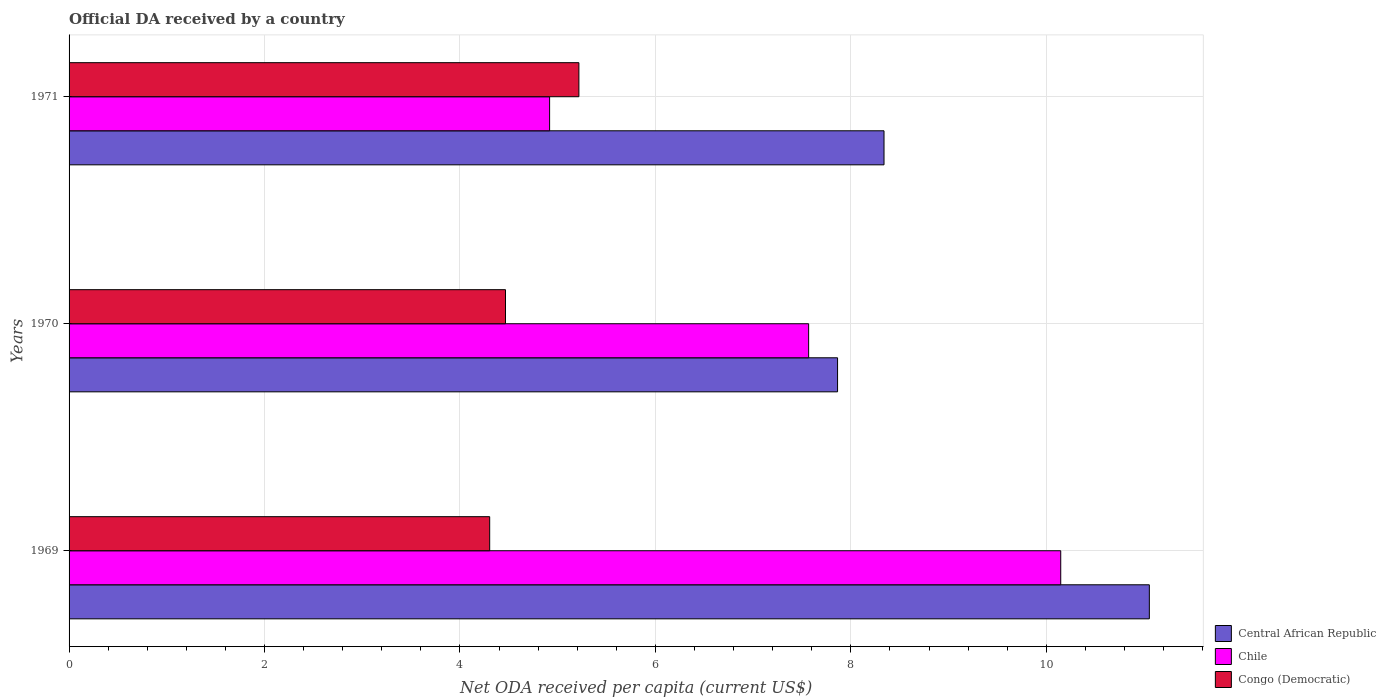How many different coloured bars are there?
Your answer should be compact. 3. How many groups of bars are there?
Your answer should be very brief. 3. Are the number of bars per tick equal to the number of legend labels?
Your answer should be very brief. Yes. How many bars are there on the 3rd tick from the bottom?
Your answer should be very brief. 3. What is the label of the 1st group of bars from the top?
Offer a very short reply. 1971. What is the ODA received in in Congo (Democratic) in 1969?
Your response must be concise. 4.3. Across all years, what is the maximum ODA received in in Chile?
Provide a succinct answer. 10.15. Across all years, what is the minimum ODA received in in Congo (Democratic)?
Keep it short and to the point. 4.3. In which year was the ODA received in in Congo (Democratic) maximum?
Provide a succinct answer. 1971. What is the total ODA received in in Congo (Democratic) in the graph?
Ensure brevity in your answer.  13.99. What is the difference between the ODA received in in Congo (Democratic) in 1969 and that in 1971?
Your answer should be compact. -0.91. What is the difference between the ODA received in in Central African Republic in 1971 and the ODA received in in Congo (Democratic) in 1969?
Give a very brief answer. 4.03. What is the average ODA received in in Congo (Democratic) per year?
Make the answer very short. 4.66. In the year 1969, what is the difference between the ODA received in in Central African Republic and ODA received in in Congo (Democratic)?
Make the answer very short. 6.75. In how many years, is the ODA received in in Central African Republic greater than 4 US$?
Give a very brief answer. 3. What is the ratio of the ODA received in in Chile in 1970 to that in 1971?
Keep it short and to the point. 1.54. Is the difference between the ODA received in in Central African Republic in 1969 and 1970 greater than the difference between the ODA received in in Congo (Democratic) in 1969 and 1970?
Make the answer very short. Yes. What is the difference between the highest and the second highest ODA received in in Congo (Democratic)?
Ensure brevity in your answer.  0.75. What is the difference between the highest and the lowest ODA received in in Congo (Democratic)?
Provide a short and direct response. 0.91. In how many years, is the ODA received in in Central African Republic greater than the average ODA received in in Central African Republic taken over all years?
Keep it short and to the point. 1. What does the 1st bar from the top in 1969 represents?
Your answer should be very brief. Congo (Democratic). What does the 1st bar from the bottom in 1971 represents?
Offer a terse response. Central African Republic. Is it the case that in every year, the sum of the ODA received in in Congo (Democratic) and ODA received in in Chile is greater than the ODA received in in Central African Republic?
Your response must be concise. Yes. Are all the bars in the graph horizontal?
Make the answer very short. Yes. How many years are there in the graph?
Your answer should be compact. 3. Are the values on the major ticks of X-axis written in scientific E-notation?
Provide a short and direct response. No. Does the graph contain any zero values?
Your answer should be compact. No. Does the graph contain grids?
Give a very brief answer. Yes. What is the title of the graph?
Your response must be concise. Official DA received by a country. What is the label or title of the X-axis?
Keep it short and to the point. Net ODA received per capita (current US$). What is the Net ODA received per capita (current US$) of Central African Republic in 1969?
Your answer should be compact. 11.05. What is the Net ODA received per capita (current US$) in Chile in 1969?
Offer a terse response. 10.15. What is the Net ODA received per capita (current US$) of Congo (Democratic) in 1969?
Your answer should be compact. 4.3. What is the Net ODA received per capita (current US$) in Central African Republic in 1970?
Provide a succinct answer. 7.86. What is the Net ODA received per capita (current US$) of Chile in 1970?
Keep it short and to the point. 7.57. What is the Net ODA received per capita (current US$) in Congo (Democratic) in 1970?
Provide a succinct answer. 4.47. What is the Net ODA received per capita (current US$) in Central African Republic in 1971?
Provide a short and direct response. 8.34. What is the Net ODA received per capita (current US$) of Chile in 1971?
Make the answer very short. 4.92. What is the Net ODA received per capita (current US$) in Congo (Democratic) in 1971?
Offer a terse response. 5.22. Across all years, what is the maximum Net ODA received per capita (current US$) in Central African Republic?
Offer a terse response. 11.05. Across all years, what is the maximum Net ODA received per capita (current US$) of Chile?
Offer a terse response. 10.15. Across all years, what is the maximum Net ODA received per capita (current US$) of Congo (Democratic)?
Keep it short and to the point. 5.22. Across all years, what is the minimum Net ODA received per capita (current US$) of Central African Republic?
Your answer should be very brief. 7.86. Across all years, what is the minimum Net ODA received per capita (current US$) of Chile?
Your answer should be compact. 4.92. Across all years, what is the minimum Net ODA received per capita (current US$) of Congo (Democratic)?
Ensure brevity in your answer.  4.3. What is the total Net ODA received per capita (current US$) of Central African Republic in the graph?
Provide a succinct answer. 27.26. What is the total Net ODA received per capita (current US$) in Chile in the graph?
Your answer should be very brief. 22.63. What is the total Net ODA received per capita (current US$) of Congo (Democratic) in the graph?
Offer a terse response. 13.99. What is the difference between the Net ODA received per capita (current US$) in Central African Republic in 1969 and that in 1970?
Your answer should be very brief. 3.19. What is the difference between the Net ODA received per capita (current US$) of Chile in 1969 and that in 1970?
Your response must be concise. 2.58. What is the difference between the Net ODA received per capita (current US$) of Congo (Democratic) in 1969 and that in 1970?
Your response must be concise. -0.16. What is the difference between the Net ODA received per capita (current US$) in Central African Republic in 1969 and that in 1971?
Keep it short and to the point. 2.71. What is the difference between the Net ODA received per capita (current US$) in Chile in 1969 and that in 1971?
Keep it short and to the point. 5.23. What is the difference between the Net ODA received per capita (current US$) in Congo (Democratic) in 1969 and that in 1971?
Your answer should be compact. -0.91. What is the difference between the Net ODA received per capita (current US$) in Central African Republic in 1970 and that in 1971?
Provide a succinct answer. -0.48. What is the difference between the Net ODA received per capita (current US$) in Chile in 1970 and that in 1971?
Give a very brief answer. 2.65. What is the difference between the Net ODA received per capita (current US$) of Congo (Democratic) in 1970 and that in 1971?
Give a very brief answer. -0.75. What is the difference between the Net ODA received per capita (current US$) of Central African Republic in 1969 and the Net ODA received per capita (current US$) of Chile in 1970?
Give a very brief answer. 3.49. What is the difference between the Net ODA received per capita (current US$) in Central African Republic in 1969 and the Net ODA received per capita (current US$) in Congo (Democratic) in 1970?
Ensure brevity in your answer.  6.59. What is the difference between the Net ODA received per capita (current US$) of Chile in 1969 and the Net ODA received per capita (current US$) of Congo (Democratic) in 1970?
Ensure brevity in your answer.  5.68. What is the difference between the Net ODA received per capita (current US$) in Central African Republic in 1969 and the Net ODA received per capita (current US$) in Chile in 1971?
Provide a succinct answer. 6.14. What is the difference between the Net ODA received per capita (current US$) of Central African Republic in 1969 and the Net ODA received per capita (current US$) of Congo (Democratic) in 1971?
Your answer should be compact. 5.84. What is the difference between the Net ODA received per capita (current US$) of Chile in 1969 and the Net ODA received per capita (current US$) of Congo (Democratic) in 1971?
Ensure brevity in your answer.  4.93. What is the difference between the Net ODA received per capita (current US$) of Central African Republic in 1970 and the Net ODA received per capita (current US$) of Chile in 1971?
Provide a short and direct response. 2.95. What is the difference between the Net ODA received per capita (current US$) of Central African Republic in 1970 and the Net ODA received per capita (current US$) of Congo (Democratic) in 1971?
Provide a succinct answer. 2.65. What is the difference between the Net ODA received per capita (current US$) in Chile in 1970 and the Net ODA received per capita (current US$) in Congo (Democratic) in 1971?
Ensure brevity in your answer.  2.35. What is the average Net ODA received per capita (current US$) in Central African Republic per year?
Keep it short and to the point. 9.09. What is the average Net ODA received per capita (current US$) of Chile per year?
Offer a terse response. 7.54. What is the average Net ODA received per capita (current US$) of Congo (Democratic) per year?
Your response must be concise. 4.66. In the year 1969, what is the difference between the Net ODA received per capita (current US$) in Central African Republic and Net ODA received per capita (current US$) in Chile?
Make the answer very short. 0.91. In the year 1969, what is the difference between the Net ODA received per capita (current US$) of Central African Republic and Net ODA received per capita (current US$) of Congo (Democratic)?
Your response must be concise. 6.75. In the year 1969, what is the difference between the Net ODA received per capita (current US$) of Chile and Net ODA received per capita (current US$) of Congo (Democratic)?
Your answer should be compact. 5.84. In the year 1970, what is the difference between the Net ODA received per capita (current US$) of Central African Republic and Net ODA received per capita (current US$) of Chile?
Make the answer very short. 0.3. In the year 1970, what is the difference between the Net ODA received per capita (current US$) of Central African Republic and Net ODA received per capita (current US$) of Congo (Democratic)?
Keep it short and to the point. 3.4. In the year 1970, what is the difference between the Net ODA received per capita (current US$) in Chile and Net ODA received per capita (current US$) in Congo (Democratic)?
Your response must be concise. 3.1. In the year 1971, what is the difference between the Net ODA received per capita (current US$) in Central African Republic and Net ODA received per capita (current US$) in Chile?
Keep it short and to the point. 3.42. In the year 1971, what is the difference between the Net ODA received per capita (current US$) in Central African Republic and Net ODA received per capita (current US$) in Congo (Democratic)?
Provide a succinct answer. 3.12. In the year 1971, what is the difference between the Net ODA received per capita (current US$) of Chile and Net ODA received per capita (current US$) of Congo (Democratic)?
Keep it short and to the point. -0.3. What is the ratio of the Net ODA received per capita (current US$) in Central African Republic in 1969 to that in 1970?
Make the answer very short. 1.41. What is the ratio of the Net ODA received per capita (current US$) of Chile in 1969 to that in 1970?
Make the answer very short. 1.34. What is the ratio of the Net ODA received per capita (current US$) of Congo (Democratic) in 1969 to that in 1970?
Give a very brief answer. 0.96. What is the ratio of the Net ODA received per capita (current US$) of Central African Republic in 1969 to that in 1971?
Offer a very short reply. 1.33. What is the ratio of the Net ODA received per capita (current US$) in Chile in 1969 to that in 1971?
Ensure brevity in your answer.  2.06. What is the ratio of the Net ODA received per capita (current US$) in Congo (Democratic) in 1969 to that in 1971?
Your answer should be very brief. 0.82. What is the ratio of the Net ODA received per capita (current US$) of Central African Republic in 1970 to that in 1971?
Your answer should be compact. 0.94. What is the ratio of the Net ODA received per capita (current US$) of Chile in 1970 to that in 1971?
Provide a succinct answer. 1.54. What is the ratio of the Net ODA received per capita (current US$) in Congo (Democratic) in 1970 to that in 1971?
Keep it short and to the point. 0.86. What is the difference between the highest and the second highest Net ODA received per capita (current US$) in Central African Republic?
Keep it short and to the point. 2.71. What is the difference between the highest and the second highest Net ODA received per capita (current US$) in Chile?
Your answer should be very brief. 2.58. What is the difference between the highest and the second highest Net ODA received per capita (current US$) of Congo (Democratic)?
Ensure brevity in your answer.  0.75. What is the difference between the highest and the lowest Net ODA received per capita (current US$) of Central African Republic?
Offer a very short reply. 3.19. What is the difference between the highest and the lowest Net ODA received per capita (current US$) of Chile?
Give a very brief answer. 5.23. What is the difference between the highest and the lowest Net ODA received per capita (current US$) in Congo (Democratic)?
Make the answer very short. 0.91. 